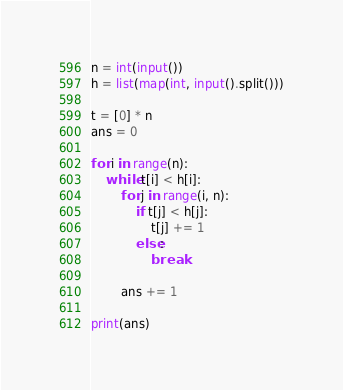<code> <loc_0><loc_0><loc_500><loc_500><_Python_>n = int(input())
h = list(map(int, input().split()))

t = [0] * n
ans = 0

for i in range(n):
    while t[i] < h[i]:
        for j in range(i, n):
            if t[j] < h[j]:
                t[j] += 1
            else:
                break

        ans += 1

print(ans)</code> 